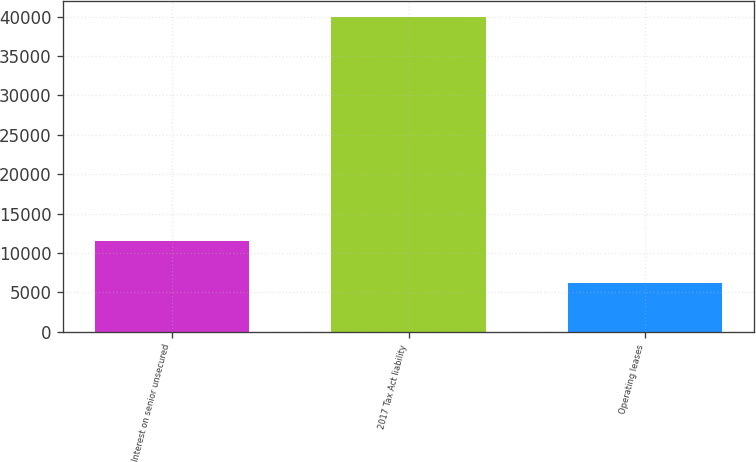Convert chart. <chart><loc_0><loc_0><loc_500><loc_500><bar_chart><fcel>Interest on senior unsecured<fcel>2017 Tax Act liability<fcel>Operating leases<nl><fcel>11467<fcel>40000<fcel>6220<nl></chart> 